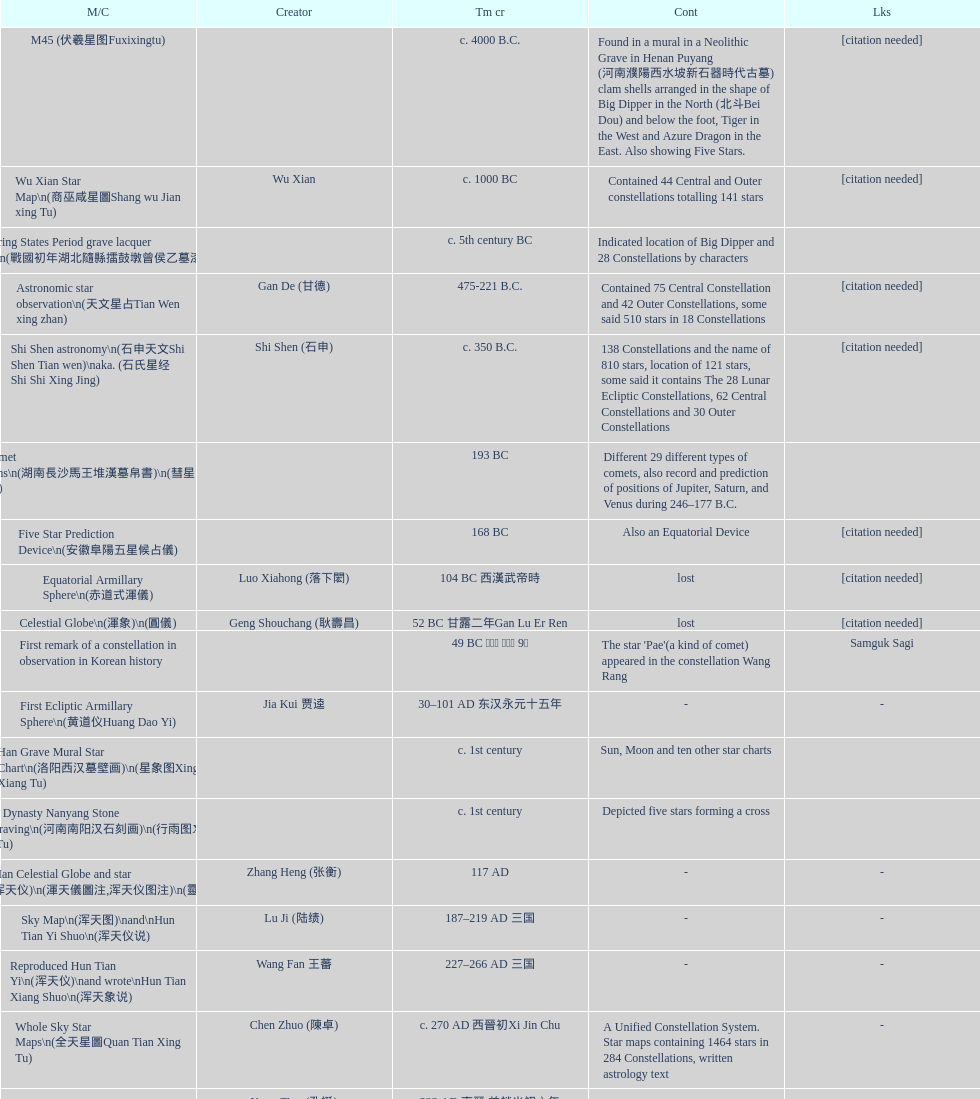When was the first map or catalog created? C. 4000 b.c. 